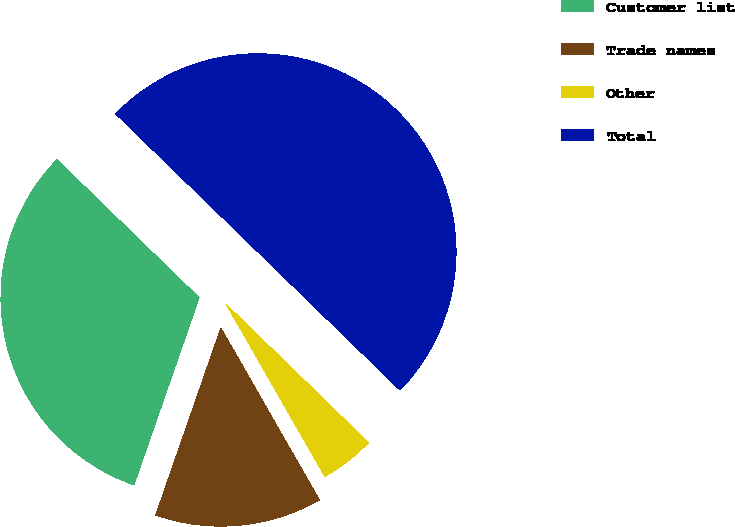Convert chart. <chart><loc_0><loc_0><loc_500><loc_500><pie_chart><fcel>Customer list<fcel>Trade names<fcel>Other<fcel>Total<nl><fcel>31.93%<fcel>13.61%<fcel>4.45%<fcel>50.0%<nl></chart> 